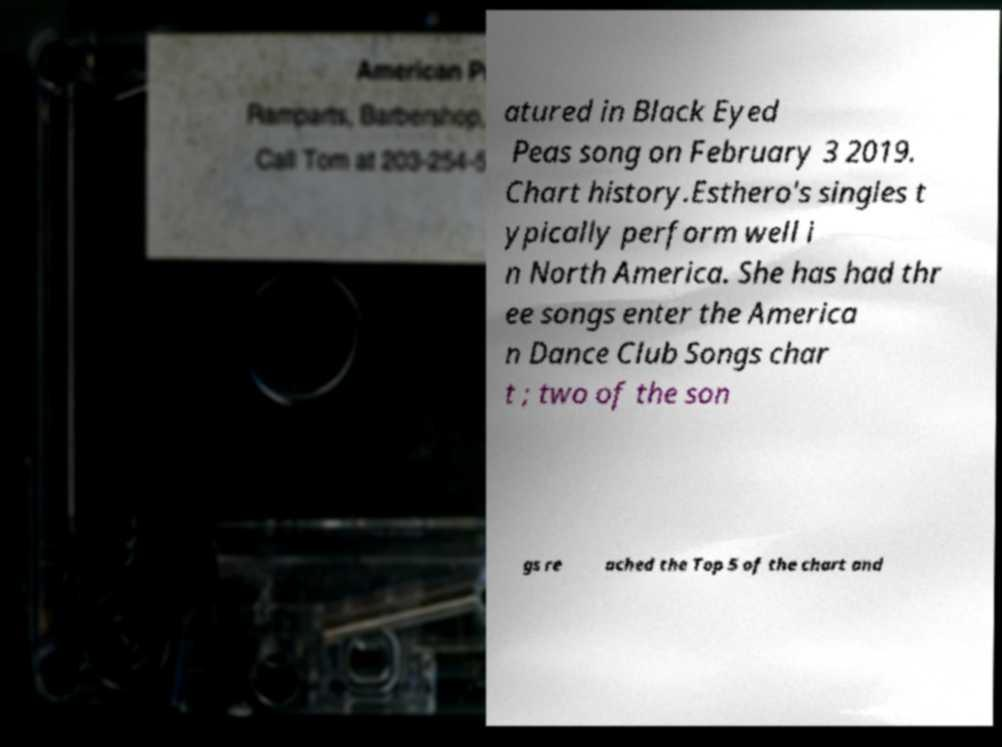Can you read and provide the text displayed in the image?This photo seems to have some interesting text. Can you extract and type it out for me? atured in Black Eyed Peas song on February 3 2019. Chart history.Esthero's singles t ypically perform well i n North America. She has had thr ee songs enter the America n Dance Club Songs char t ; two of the son gs re ached the Top 5 of the chart and 